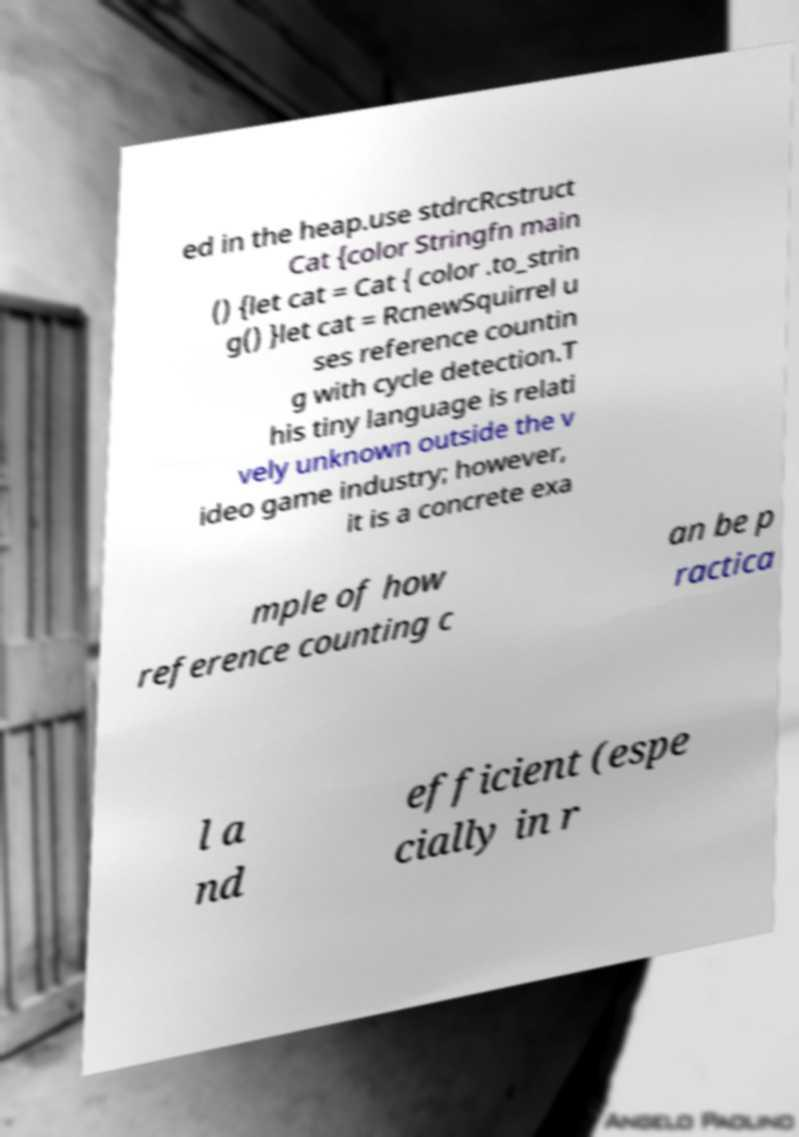Could you extract and type out the text from this image? ed in the heap.use stdrcRcstruct Cat {color Stringfn main () {let cat = Cat { color .to_strin g() }let cat = RcnewSquirrel u ses reference countin g with cycle detection.T his tiny language is relati vely unknown outside the v ideo game industry; however, it is a concrete exa mple of how reference counting c an be p ractica l a nd efficient (espe cially in r 